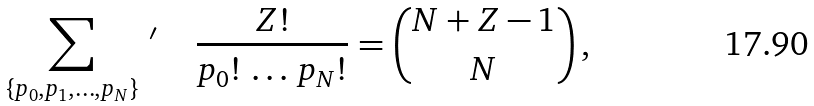<formula> <loc_0><loc_0><loc_500><loc_500>\sum _ { \{ p _ { 0 } , p _ { 1 } , \dots , p _ { N } \} } \, { ^ { \prime } } \quad \, \frac { Z ! } { p _ { 0 } ! \, \dots \, p _ { N } ! } = { N + Z - 1 \choose N } \, ,</formula> 